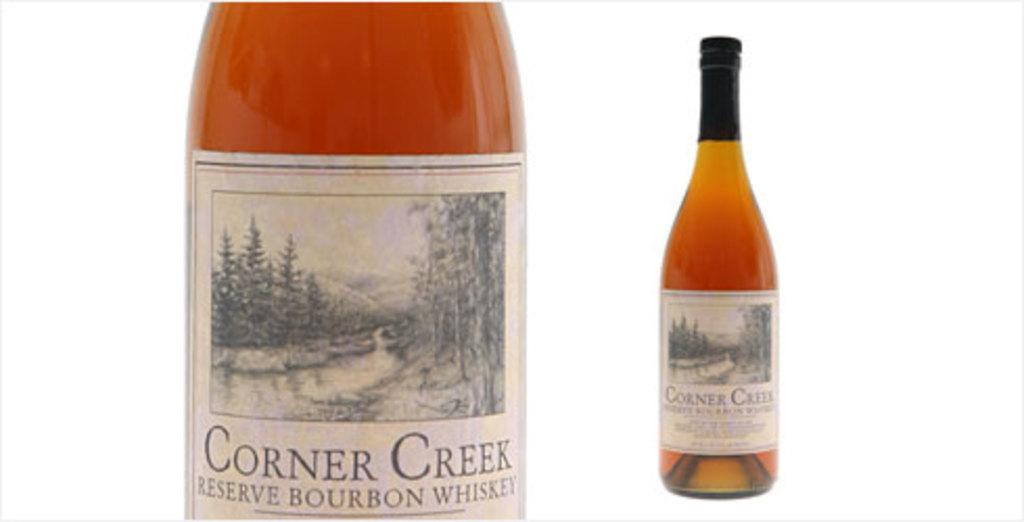<image>
Relay a brief, clear account of the picture shown. A bottle Corner Creek whiskey has a label with an outdoor scene. 